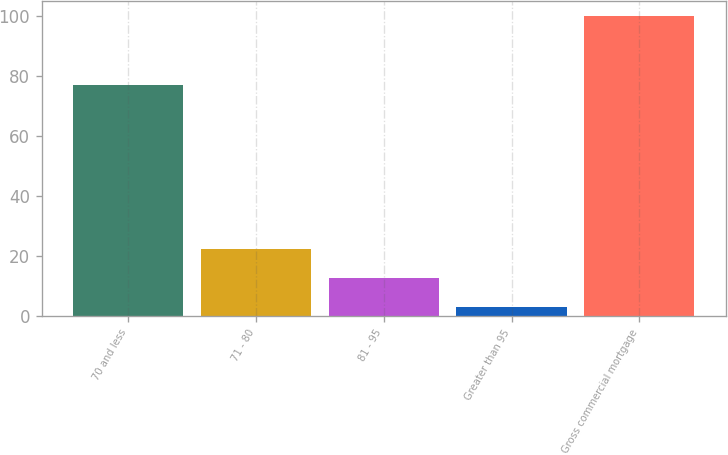Convert chart to OTSL. <chart><loc_0><loc_0><loc_500><loc_500><bar_chart><fcel>70 and less<fcel>71 - 80<fcel>81 - 95<fcel>Greater than 95<fcel>Gross commercial mortgage<nl><fcel>77.1<fcel>22.32<fcel>12.61<fcel>2.9<fcel>100<nl></chart> 